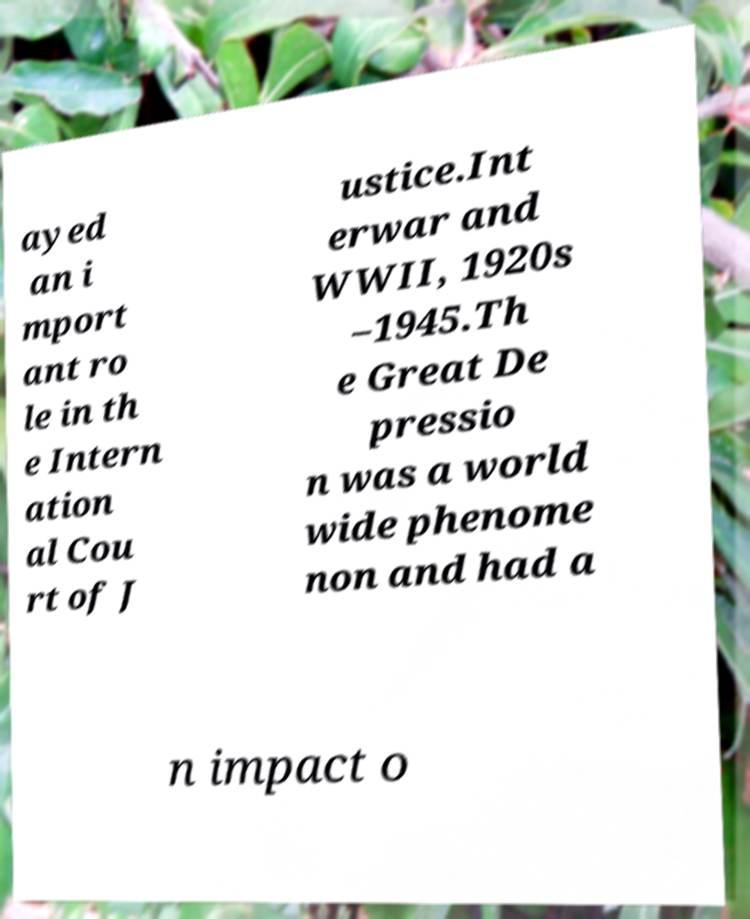I need the written content from this picture converted into text. Can you do that? ayed an i mport ant ro le in th e Intern ation al Cou rt of J ustice.Int erwar and WWII, 1920s –1945.Th e Great De pressio n was a world wide phenome non and had a n impact o 